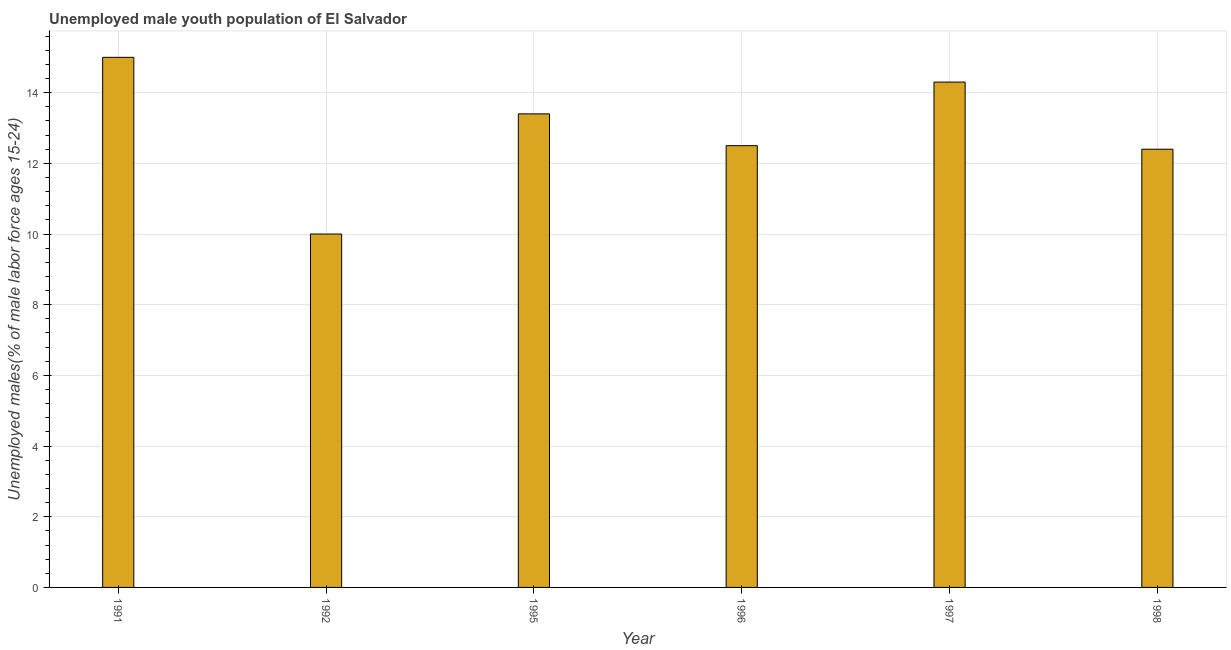What is the title of the graph?
Your response must be concise. Unemployed male youth population of El Salvador. What is the label or title of the Y-axis?
Make the answer very short. Unemployed males(% of male labor force ages 15-24). Across all years, what is the maximum unemployed male youth?
Keep it short and to the point. 15. Across all years, what is the minimum unemployed male youth?
Your answer should be compact. 10. In which year was the unemployed male youth maximum?
Provide a succinct answer. 1991. In which year was the unemployed male youth minimum?
Keep it short and to the point. 1992. What is the sum of the unemployed male youth?
Your response must be concise. 77.6. What is the difference between the unemployed male youth in 1992 and 1998?
Your answer should be compact. -2.4. What is the average unemployed male youth per year?
Keep it short and to the point. 12.93. What is the median unemployed male youth?
Keep it short and to the point. 12.95. In how many years, is the unemployed male youth greater than 9.6 %?
Ensure brevity in your answer.  6. What is the ratio of the unemployed male youth in 1996 to that in 1997?
Keep it short and to the point. 0.87. Is the difference between the unemployed male youth in 1995 and 1997 greater than the difference between any two years?
Give a very brief answer. No. What is the difference between the highest and the second highest unemployed male youth?
Your response must be concise. 0.7. What is the difference between the highest and the lowest unemployed male youth?
Your response must be concise. 5. In how many years, is the unemployed male youth greater than the average unemployed male youth taken over all years?
Ensure brevity in your answer.  3. What is the difference between two consecutive major ticks on the Y-axis?
Provide a short and direct response. 2. Are the values on the major ticks of Y-axis written in scientific E-notation?
Provide a short and direct response. No. What is the Unemployed males(% of male labor force ages 15-24) in 1991?
Provide a succinct answer. 15. What is the Unemployed males(% of male labor force ages 15-24) of 1992?
Your answer should be compact. 10. What is the Unemployed males(% of male labor force ages 15-24) in 1995?
Offer a terse response. 13.4. What is the Unemployed males(% of male labor force ages 15-24) in 1996?
Keep it short and to the point. 12.5. What is the Unemployed males(% of male labor force ages 15-24) in 1997?
Provide a succinct answer. 14.3. What is the Unemployed males(% of male labor force ages 15-24) in 1998?
Your response must be concise. 12.4. What is the difference between the Unemployed males(% of male labor force ages 15-24) in 1991 and 1992?
Ensure brevity in your answer.  5. What is the difference between the Unemployed males(% of male labor force ages 15-24) in 1991 and 1995?
Your answer should be compact. 1.6. What is the difference between the Unemployed males(% of male labor force ages 15-24) in 1991 and 1997?
Give a very brief answer. 0.7. What is the difference between the Unemployed males(% of male labor force ages 15-24) in 1991 and 1998?
Your answer should be very brief. 2.6. What is the difference between the Unemployed males(% of male labor force ages 15-24) in 1992 and 1996?
Your response must be concise. -2.5. What is the difference between the Unemployed males(% of male labor force ages 15-24) in 1992 and 1998?
Offer a terse response. -2.4. What is the difference between the Unemployed males(% of male labor force ages 15-24) in 1995 and 1997?
Keep it short and to the point. -0.9. What is the difference between the Unemployed males(% of male labor force ages 15-24) in 1995 and 1998?
Provide a succinct answer. 1. What is the ratio of the Unemployed males(% of male labor force ages 15-24) in 1991 to that in 1995?
Your answer should be very brief. 1.12. What is the ratio of the Unemployed males(% of male labor force ages 15-24) in 1991 to that in 1996?
Make the answer very short. 1.2. What is the ratio of the Unemployed males(% of male labor force ages 15-24) in 1991 to that in 1997?
Make the answer very short. 1.05. What is the ratio of the Unemployed males(% of male labor force ages 15-24) in 1991 to that in 1998?
Your response must be concise. 1.21. What is the ratio of the Unemployed males(% of male labor force ages 15-24) in 1992 to that in 1995?
Provide a short and direct response. 0.75. What is the ratio of the Unemployed males(% of male labor force ages 15-24) in 1992 to that in 1996?
Ensure brevity in your answer.  0.8. What is the ratio of the Unemployed males(% of male labor force ages 15-24) in 1992 to that in 1997?
Provide a short and direct response. 0.7. What is the ratio of the Unemployed males(% of male labor force ages 15-24) in 1992 to that in 1998?
Provide a succinct answer. 0.81. What is the ratio of the Unemployed males(% of male labor force ages 15-24) in 1995 to that in 1996?
Your answer should be very brief. 1.07. What is the ratio of the Unemployed males(% of male labor force ages 15-24) in 1995 to that in 1997?
Make the answer very short. 0.94. What is the ratio of the Unemployed males(% of male labor force ages 15-24) in 1995 to that in 1998?
Offer a very short reply. 1.08. What is the ratio of the Unemployed males(% of male labor force ages 15-24) in 1996 to that in 1997?
Offer a terse response. 0.87. What is the ratio of the Unemployed males(% of male labor force ages 15-24) in 1996 to that in 1998?
Your answer should be very brief. 1.01. What is the ratio of the Unemployed males(% of male labor force ages 15-24) in 1997 to that in 1998?
Provide a short and direct response. 1.15. 